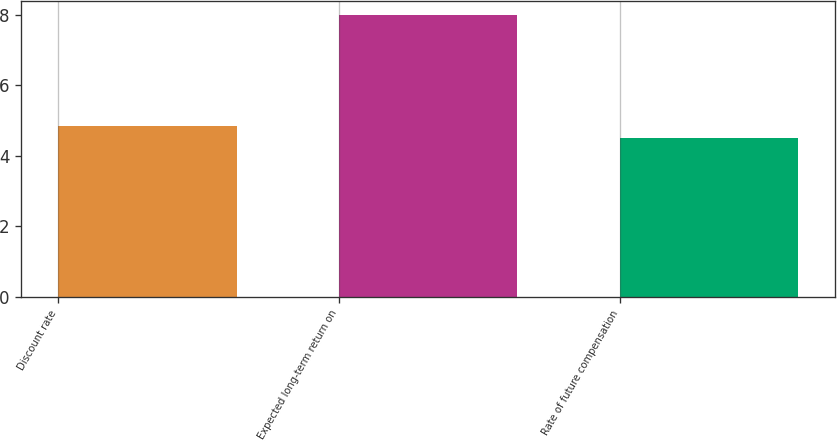Convert chart to OTSL. <chart><loc_0><loc_0><loc_500><loc_500><bar_chart><fcel>Discount rate<fcel>Expected long-term return on<fcel>Rate of future compensation<nl><fcel>4.85<fcel>8<fcel>4.5<nl></chart> 